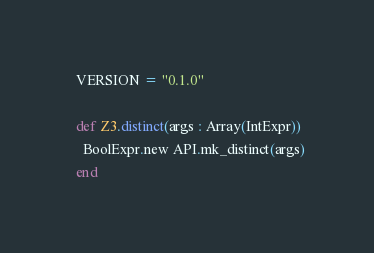Convert code to text. <code><loc_0><loc_0><loc_500><loc_500><_Crystal_>  VERSION = "0.1.0"

  def Z3.distinct(args : Array(IntExpr))
    BoolExpr.new API.mk_distinct(args)
  end
</code> 